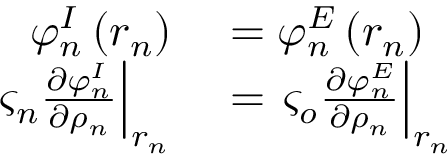Convert formula to latex. <formula><loc_0><loc_0><loc_500><loc_500>\begin{array} { r l } { \varphi _ { n } ^ { I } \left ( r _ { n } \right ) } & = \varphi _ { n } ^ { E } \left ( r _ { n } \right ) } \\ { \varsigma _ { n } \frac { \partial \varphi _ { n } ^ { I } } { \partial \rho _ { n } } \right | _ { r _ { n } } } & = \varsigma _ { o } \frac { \partial \varphi _ { n } ^ { E } } { \partial \rho _ { n } } \right | _ { r _ { n } } } \end{array}</formula> 